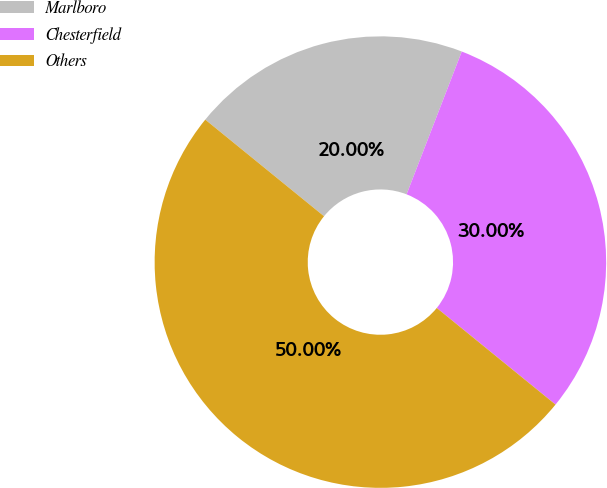Convert chart to OTSL. <chart><loc_0><loc_0><loc_500><loc_500><pie_chart><fcel>Marlboro<fcel>Chesterfield<fcel>Others<nl><fcel>20.0%<fcel>30.0%<fcel>50.0%<nl></chart> 